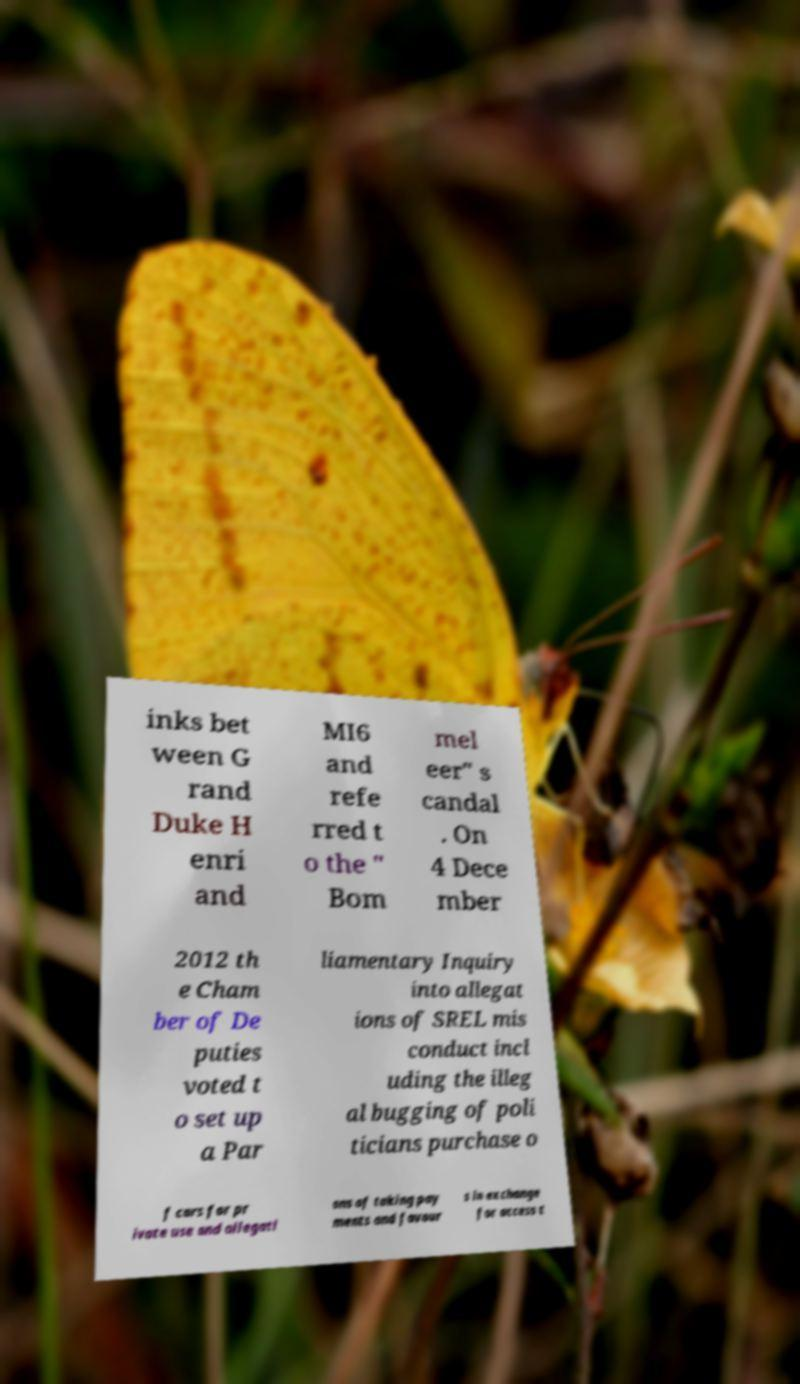What messages or text are displayed in this image? I need them in a readable, typed format. inks bet ween G rand Duke H enri and MI6 and refe rred t o the " Bom mel eer" s candal . On 4 Dece mber 2012 th e Cham ber of De puties voted t o set up a Par liamentary Inquiry into allegat ions of SREL mis conduct incl uding the illeg al bugging of poli ticians purchase o f cars for pr ivate use and allegati ons of taking pay ments and favour s in exchange for access t 